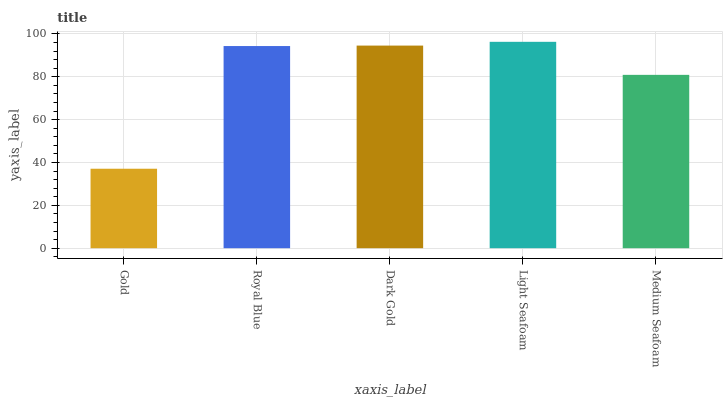Is Gold the minimum?
Answer yes or no. Yes. Is Light Seafoam the maximum?
Answer yes or no. Yes. Is Royal Blue the minimum?
Answer yes or no. No. Is Royal Blue the maximum?
Answer yes or no. No. Is Royal Blue greater than Gold?
Answer yes or no. Yes. Is Gold less than Royal Blue?
Answer yes or no. Yes. Is Gold greater than Royal Blue?
Answer yes or no. No. Is Royal Blue less than Gold?
Answer yes or no. No. Is Royal Blue the high median?
Answer yes or no. Yes. Is Royal Blue the low median?
Answer yes or no. Yes. Is Light Seafoam the high median?
Answer yes or no. No. Is Gold the low median?
Answer yes or no. No. 